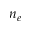Convert formula to latex. <formula><loc_0><loc_0><loc_500><loc_500>n _ { e }</formula> 